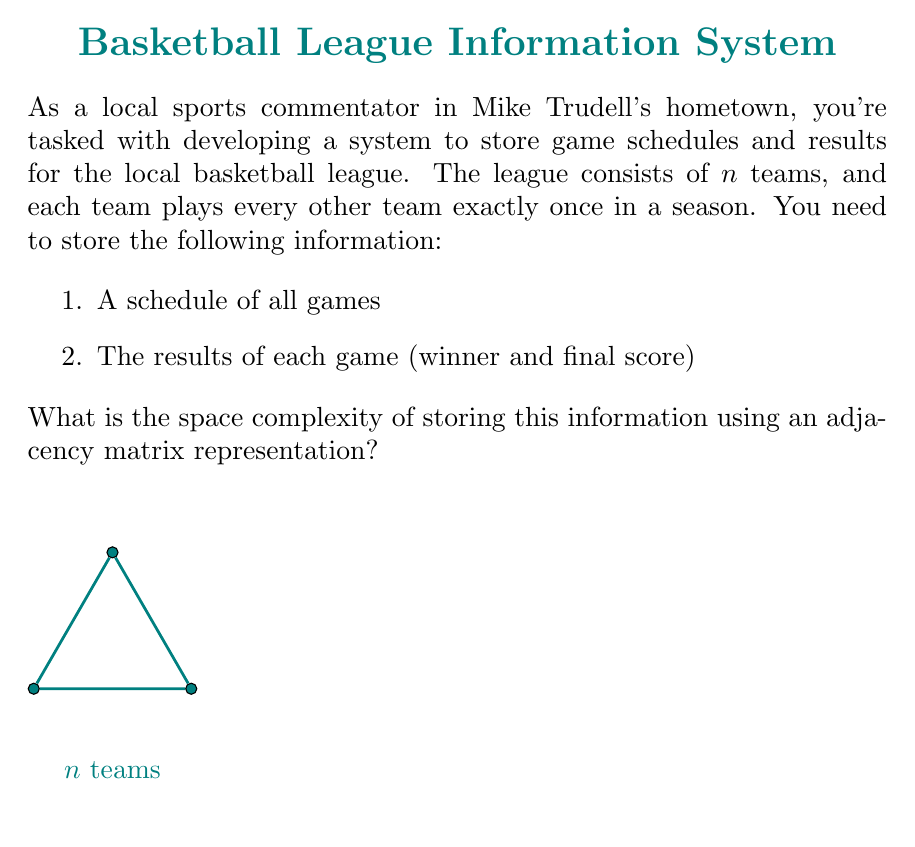Can you solve this math problem? Let's break this down step-by-step:

1) First, we need to determine the number of games in a season:
   - Each team plays every other team once
   - This forms a complete graph with $n$ nodes (teams)
   - The number of edges (games) in a complete graph is given by the formula:
     $$\text{Number of games} = \frac{n(n-1)}{2}$$

2) Now, let's consider the adjacency matrix representation:
   - An adjacency matrix for $n$ teams would be an $n \times n$ matrix
   - We only need to store information in the upper triangular part (excluding diagonal) because:
     a) Teams don't play themselves (diagonal is always empty)
     b) If team A plays team B, we don't need to store that team B plays team A separately

3) For each game, we need to store:
   - The fact that the game exists (implicit in the matrix structure)
   - The winner (can be represented by a binary value)
   - The score (let's assume we use two integers for each team's score)

4) So, for each cell in the upper triangular part of the matrix, we need to store 3 values (1 for winner, 2 for scores)

5) The number of cells in the upper triangular part (excluding diagonal) is exactly the number of games: $\frac{n(n-1)}{2}$

6) Therefore, the total space required is:
   $$\text{Space} = 3 \cdot \frac{n(n-1)}{2} = \frac{3n(n-1)}{2}$$

7) In Big O notation, we ignore constants and lower-order terms. So the space complexity is $O(n^2)$.
Answer: $O(n^2)$ 